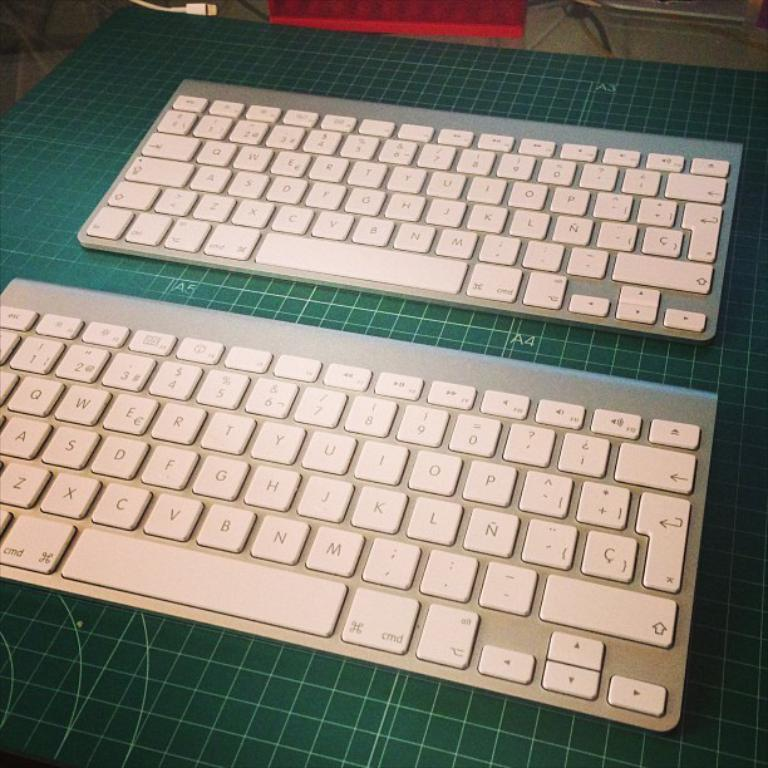What type of devices are present in the image? There are keyboards in the image. Are there any visible connections between the devices or other objects in the image? Yes, there are wires visible in the image. What type of friction can be observed between the keyboards in the image? There is no friction between the keyboards in the image, as they are not in contact with each other. 